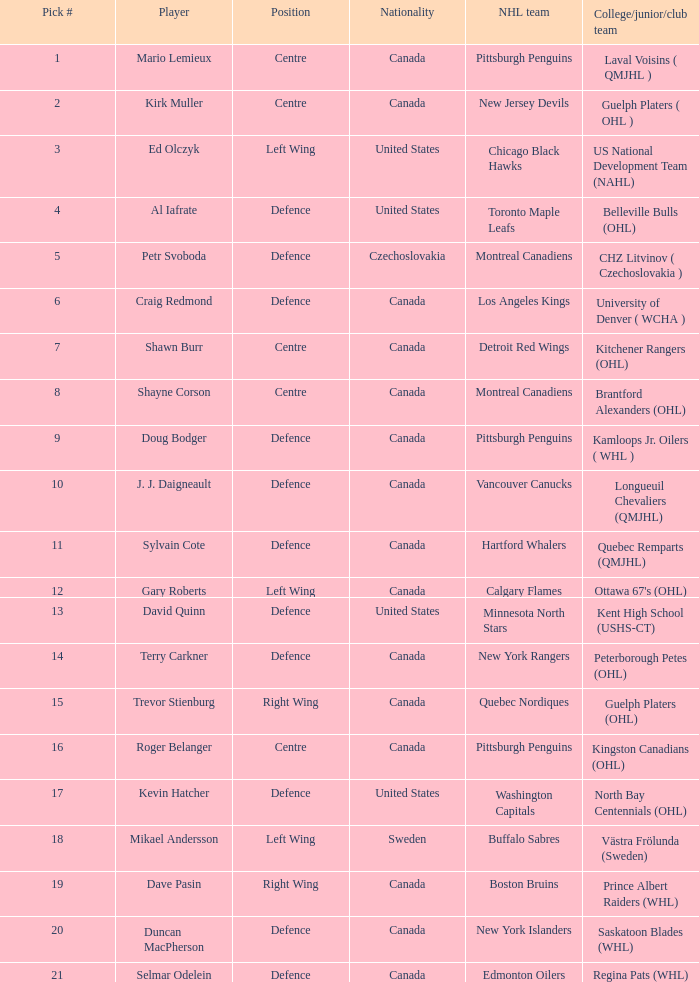Who holds the position of draft pick number 17? Kevin Hatcher. Could you parse the entire table as a dict? {'header': ['Pick #', 'Player', 'Position', 'Nationality', 'NHL team', 'College/junior/club team'], 'rows': [['1', 'Mario Lemieux', 'Centre', 'Canada', 'Pittsburgh Penguins', 'Laval Voisins ( QMJHL )'], ['2', 'Kirk Muller', 'Centre', 'Canada', 'New Jersey Devils', 'Guelph Platers ( OHL )'], ['3', 'Ed Olczyk', 'Left Wing', 'United States', 'Chicago Black Hawks', 'US National Development Team (NAHL)'], ['4', 'Al Iafrate', 'Defence', 'United States', 'Toronto Maple Leafs', 'Belleville Bulls (OHL)'], ['5', 'Petr Svoboda', 'Defence', 'Czechoslovakia', 'Montreal Canadiens', 'CHZ Litvinov ( Czechoslovakia )'], ['6', 'Craig Redmond', 'Defence', 'Canada', 'Los Angeles Kings', 'University of Denver ( WCHA )'], ['7', 'Shawn Burr', 'Centre', 'Canada', 'Detroit Red Wings', 'Kitchener Rangers (OHL)'], ['8', 'Shayne Corson', 'Centre', 'Canada', 'Montreal Canadiens', 'Brantford Alexanders (OHL)'], ['9', 'Doug Bodger', 'Defence', 'Canada', 'Pittsburgh Penguins', 'Kamloops Jr. Oilers ( WHL )'], ['10', 'J. J. Daigneault', 'Defence', 'Canada', 'Vancouver Canucks', 'Longueuil Chevaliers (QMJHL)'], ['11', 'Sylvain Cote', 'Defence', 'Canada', 'Hartford Whalers', 'Quebec Remparts (QMJHL)'], ['12', 'Gary Roberts', 'Left Wing', 'Canada', 'Calgary Flames', "Ottawa 67's (OHL)"], ['13', 'David Quinn', 'Defence', 'United States', 'Minnesota North Stars', 'Kent High School (USHS-CT)'], ['14', 'Terry Carkner', 'Defence', 'Canada', 'New York Rangers', 'Peterborough Petes (OHL)'], ['15', 'Trevor Stienburg', 'Right Wing', 'Canada', 'Quebec Nordiques', 'Guelph Platers (OHL)'], ['16', 'Roger Belanger', 'Centre', 'Canada', 'Pittsburgh Penguins', 'Kingston Canadians (OHL)'], ['17', 'Kevin Hatcher', 'Defence', 'United States', 'Washington Capitals', 'North Bay Centennials (OHL)'], ['18', 'Mikael Andersson', 'Left Wing', 'Sweden', 'Buffalo Sabres', 'Västra Frölunda (Sweden)'], ['19', 'Dave Pasin', 'Right Wing', 'Canada', 'Boston Bruins', 'Prince Albert Raiders (WHL)'], ['20', 'Duncan MacPherson', 'Defence', 'Canada', 'New York Islanders', 'Saskatoon Blades (WHL)'], ['21', 'Selmar Odelein', 'Defence', 'Canada', 'Edmonton Oilers', 'Regina Pats (WHL)']]} 